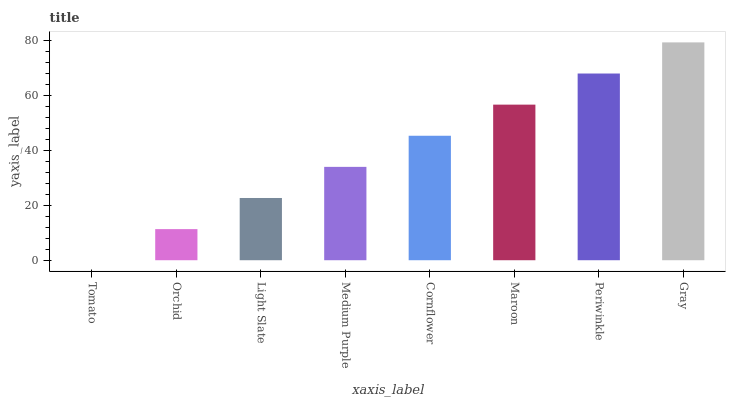Is Tomato the minimum?
Answer yes or no. Yes. Is Gray the maximum?
Answer yes or no. Yes. Is Orchid the minimum?
Answer yes or no. No. Is Orchid the maximum?
Answer yes or no. No. Is Orchid greater than Tomato?
Answer yes or no. Yes. Is Tomato less than Orchid?
Answer yes or no. Yes. Is Tomato greater than Orchid?
Answer yes or no. No. Is Orchid less than Tomato?
Answer yes or no. No. Is Cornflower the high median?
Answer yes or no. Yes. Is Medium Purple the low median?
Answer yes or no. Yes. Is Tomato the high median?
Answer yes or no. No. Is Light Slate the low median?
Answer yes or no. No. 